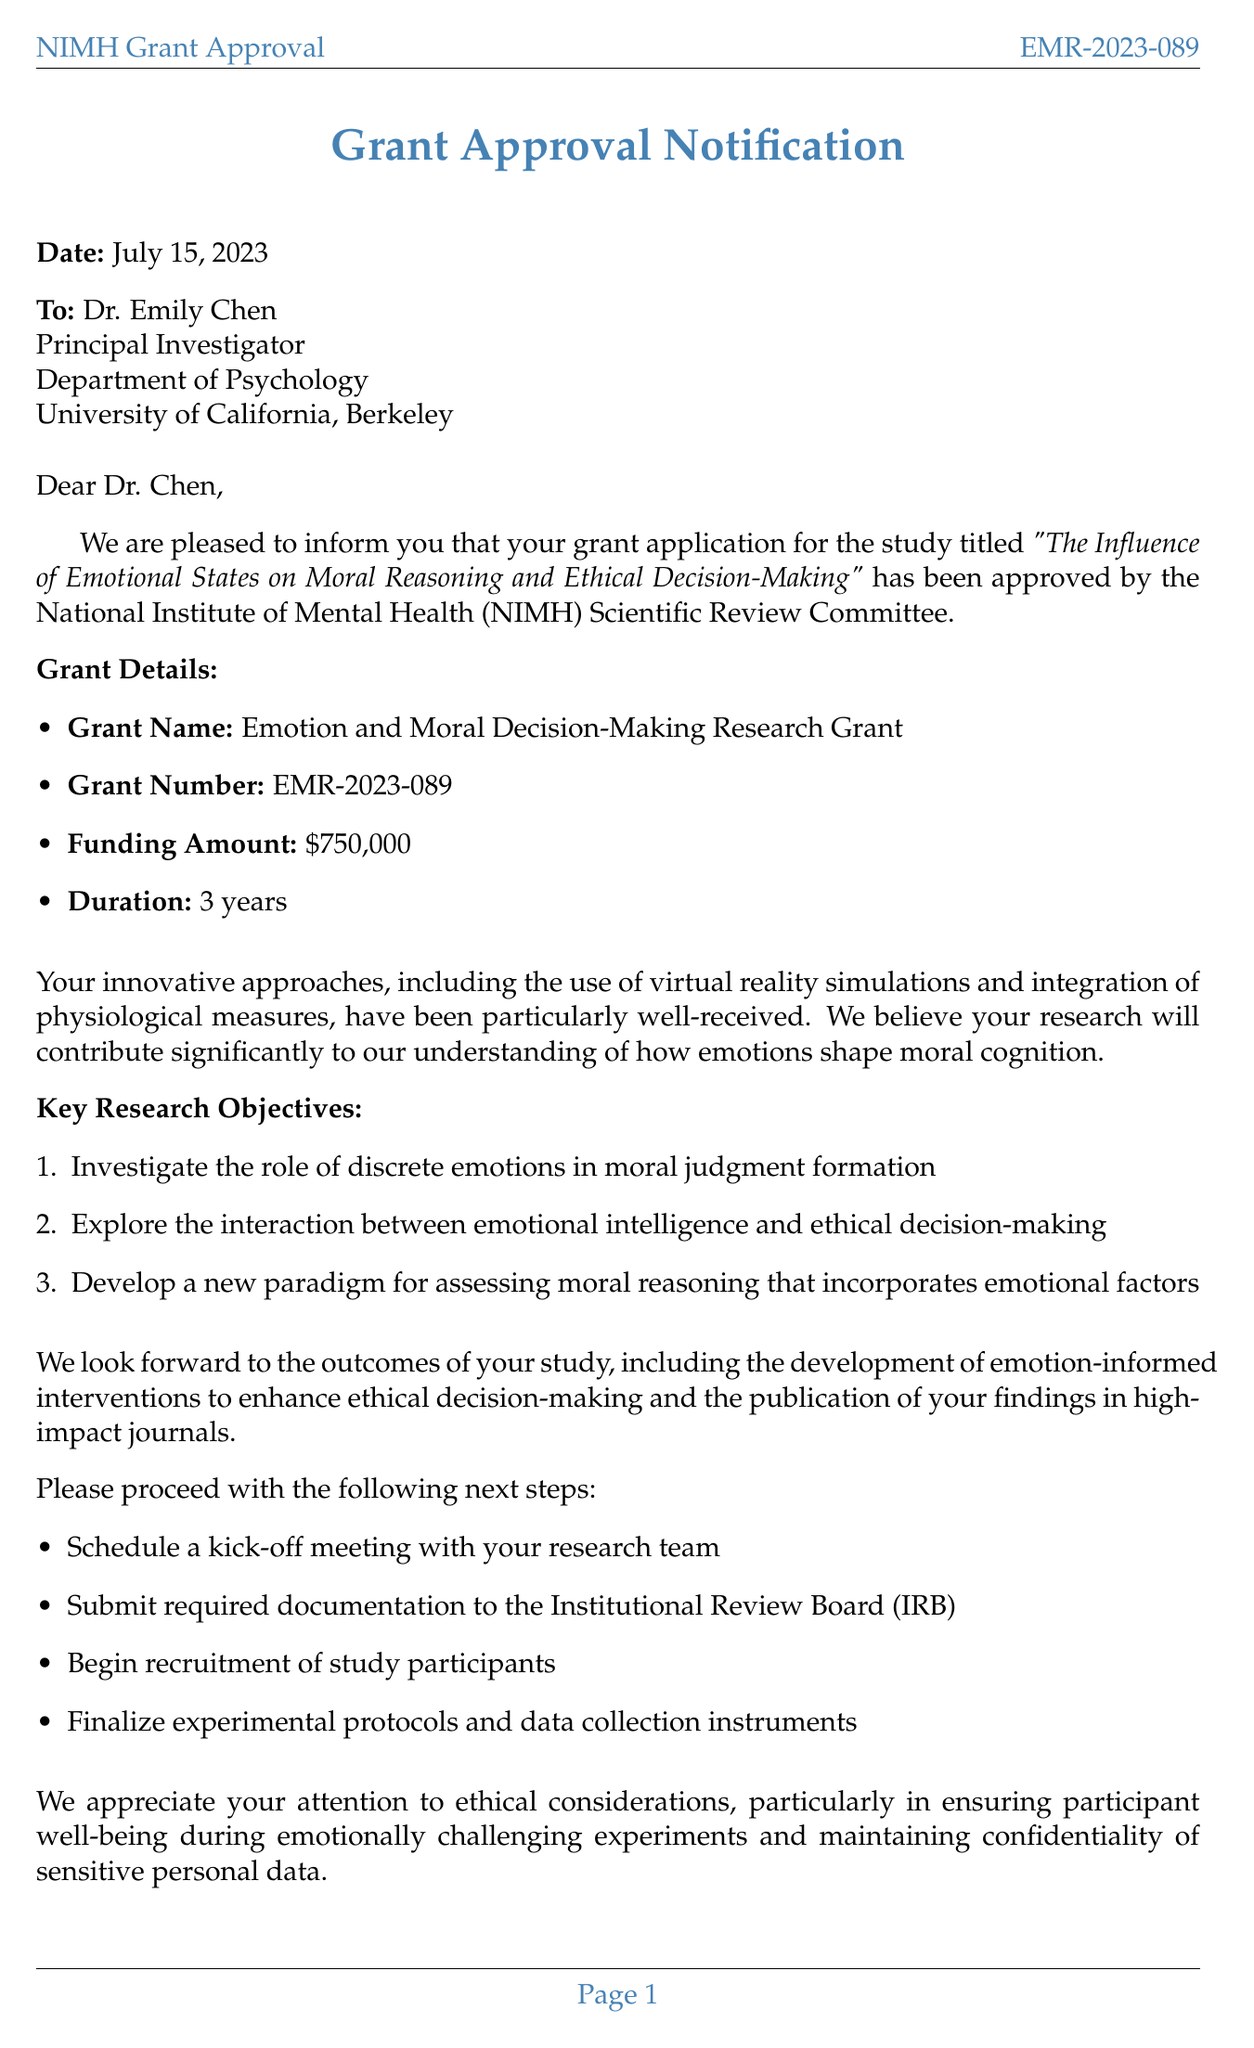What is the grant name? The grant name is explicitly mentioned in the document as "Emotion and Moral Decision-Making Research Grant."
Answer: Emotion and Moral Decision-Making Research Grant Who is the principal investigator? The document names Dr. Emily Chen as the principal investigator of the study.
Answer: Dr. Emily Chen What is the funding amount awarded? The funding amount stated in the document is $750,000.
Answer: $750,000 What is the duration of the grant? The duration of the grant outlined in the document is 3 years.
Answer: 3 years When was the grant approval date? The date of grant approval is explicitly mentioned in the document as July 15, 2023.
Answer: July 15, 2023 Which institution is hosting the research? The document specifies that the research is being hosted at the University of California, Berkeley.
Answer: University of California, Berkeley What are the expected outcomes of the study? The document lists several expected outcomes, including publication of articles and development of interventions.
Answer: Publication of at least 3 peer-reviewed articles in high-impact journals What ethical considerations are mentioned in the document? The document outlines various ethical considerations, including participant well-being and data confidentiality.
Answer: Ensuring participant well-being during emotionally challenging experiments What innovative approaches will be used in the study? The document describes the use of virtual reality simulations as one of the innovative approaches.
Answer: Use of virtual reality simulations to create emotionally charged moral dilemmas 